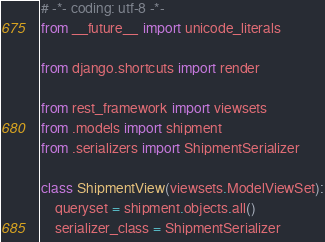<code> <loc_0><loc_0><loc_500><loc_500><_Python_># -*- coding: utf-8 -*-
from __future__ import unicode_literals

from django.shortcuts import render

from rest_framework import viewsets
from .models import shipment
from .serializers import ShipmentSerializer

class ShipmentView(viewsets.ModelViewSet):
    queryset = shipment.objects.all()
    serializer_class = ShipmentSerializer
</code> 